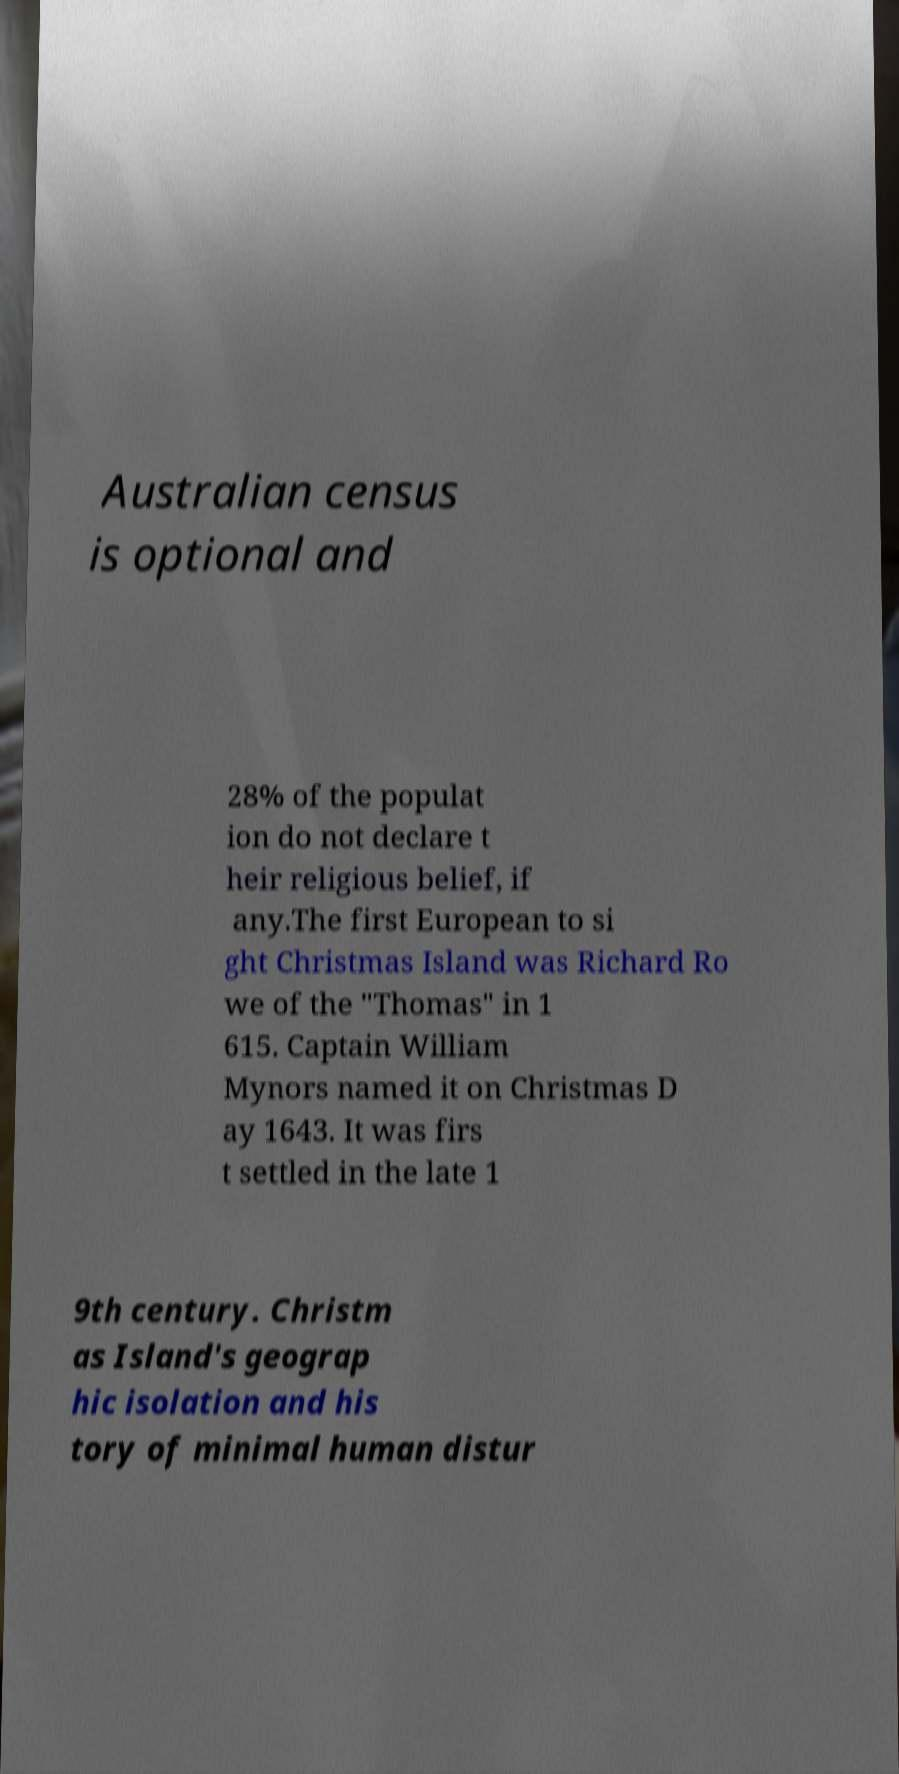For documentation purposes, I need the text within this image transcribed. Could you provide that? Australian census is optional and 28% of the populat ion do not declare t heir religious belief, if any.The first European to si ght Christmas Island was Richard Ro we of the "Thomas" in 1 615. Captain William Mynors named it on Christmas D ay 1643. It was firs t settled in the late 1 9th century. Christm as Island's geograp hic isolation and his tory of minimal human distur 